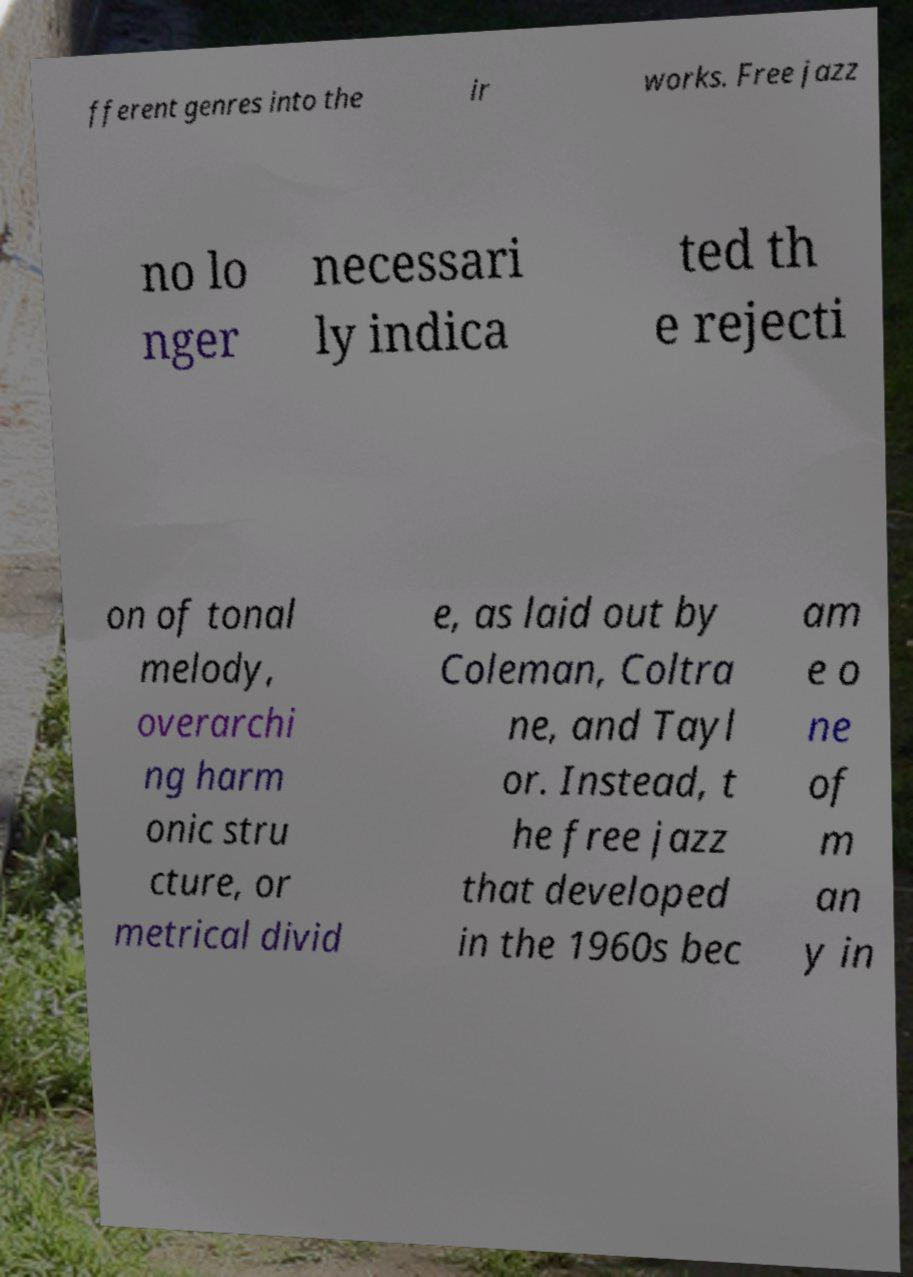Could you extract and type out the text from this image? fferent genres into the ir works. Free jazz no lo nger necessari ly indica ted th e rejecti on of tonal melody, overarchi ng harm onic stru cture, or metrical divid e, as laid out by Coleman, Coltra ne, and Tayl or. Instead, t he free jazz that developed in the 1960s bec am e o ne of m an y in 